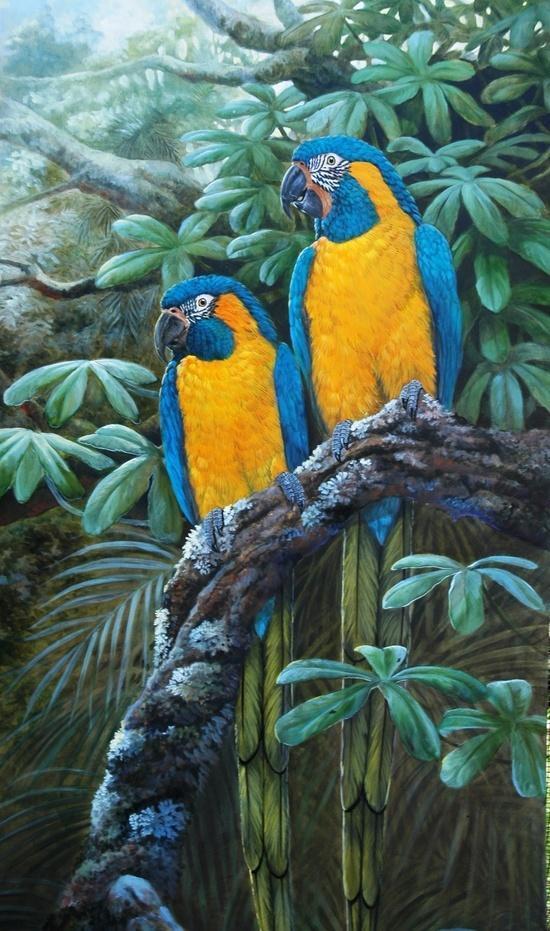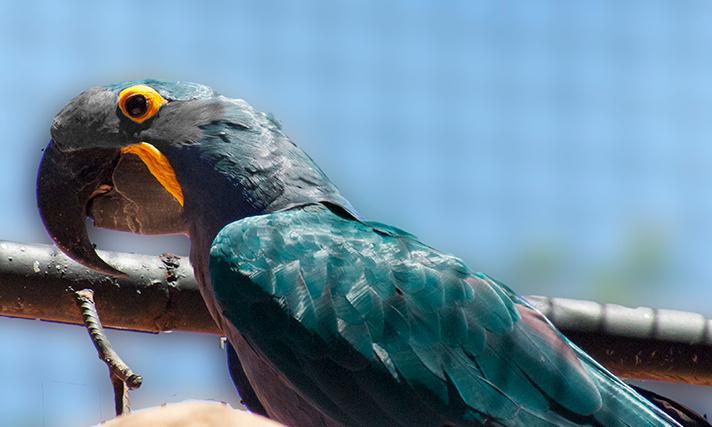The first image is the image on the left, the second image is the image on the right. Assess this claim about the two images: "There is at least one yellow breasted bird in the image on the left.". Correct or not? Answer yes or no. Yes. 